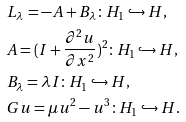Convert formula to latex. <formula><loc_0><loc_0><loc_500><loc_500>& L _ { \lambda } = - A + B _ { \lambda } \colon H _ { 1 } \hookrightarrow H , \\ & A = ( I + \frac { \partial ^ { 2 } u } { \partial x ^ { 2 } } ) ^ { 2 } \colon H _ { 1 } \hookrightarrow H , \\ & B _ { \lambda } = \lambda I \colon H _ { 1 } \hookrightarrow H , \\ & G u = \mu u ^ { 2 } - u ^ { 3 } \colon H _ { 1 } \hookrightarrow H . \\</formula> 